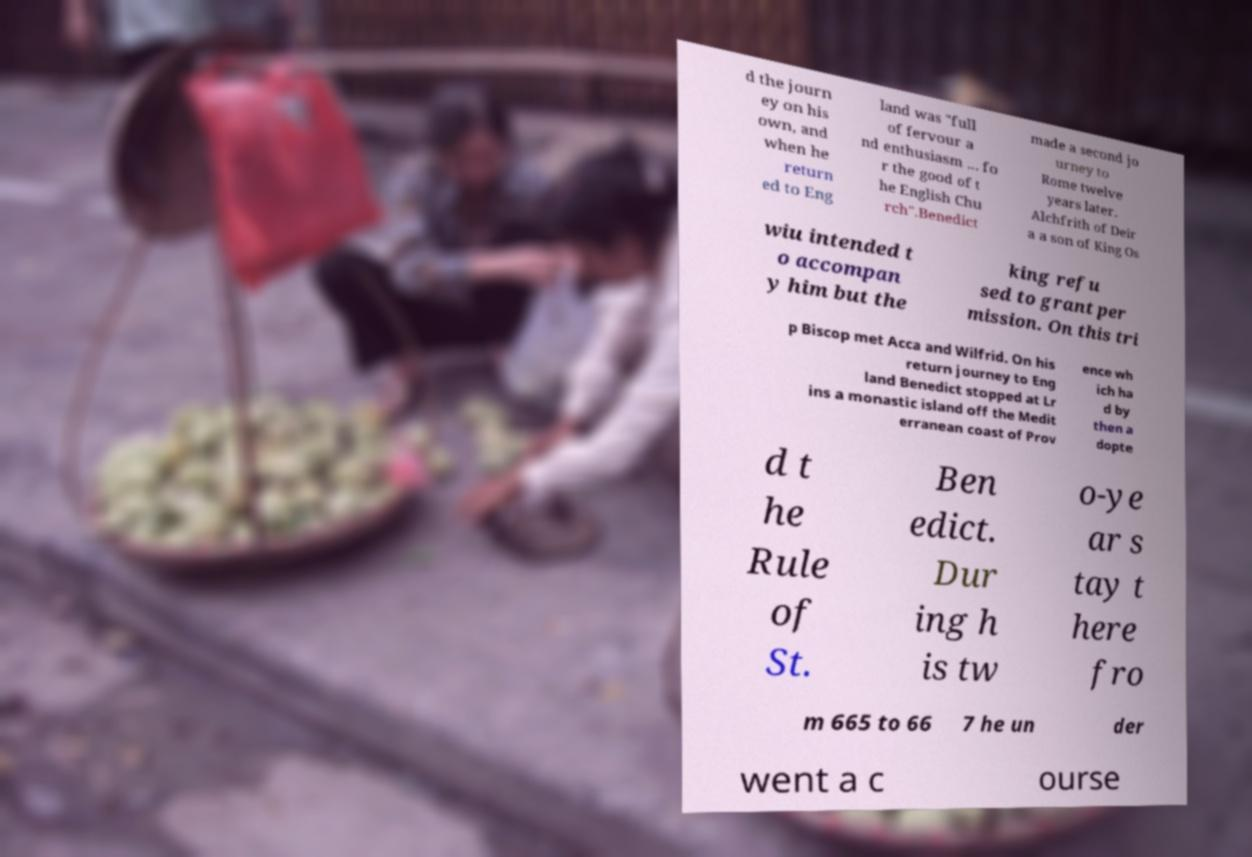Can you accurately transcribe the text from the provided image for me? d the journ ey on his own, and when he return ed to Eng land was "full of fervour a nd enthusiasm ... fo r the good of t he English Chu rch".Benedict made a second jo urney to Rome twelve years later. Alchfrith of Deir a a son of King Os wiu intended t o accompan y him but the king refu sed to grant per mission. On this tri p Biscop met Acca and Wilfrid. On his return journey to Eng land Benedict stopped at Lr ins a monastic island off the Medit erranean coast of Prov ence wh ich ha d by then a dopte d t he Rule of St. Ben edict. Dur ing h is tw o-ye ar s tay t here fro m 665 to 66 7 he un der went a c ourse 